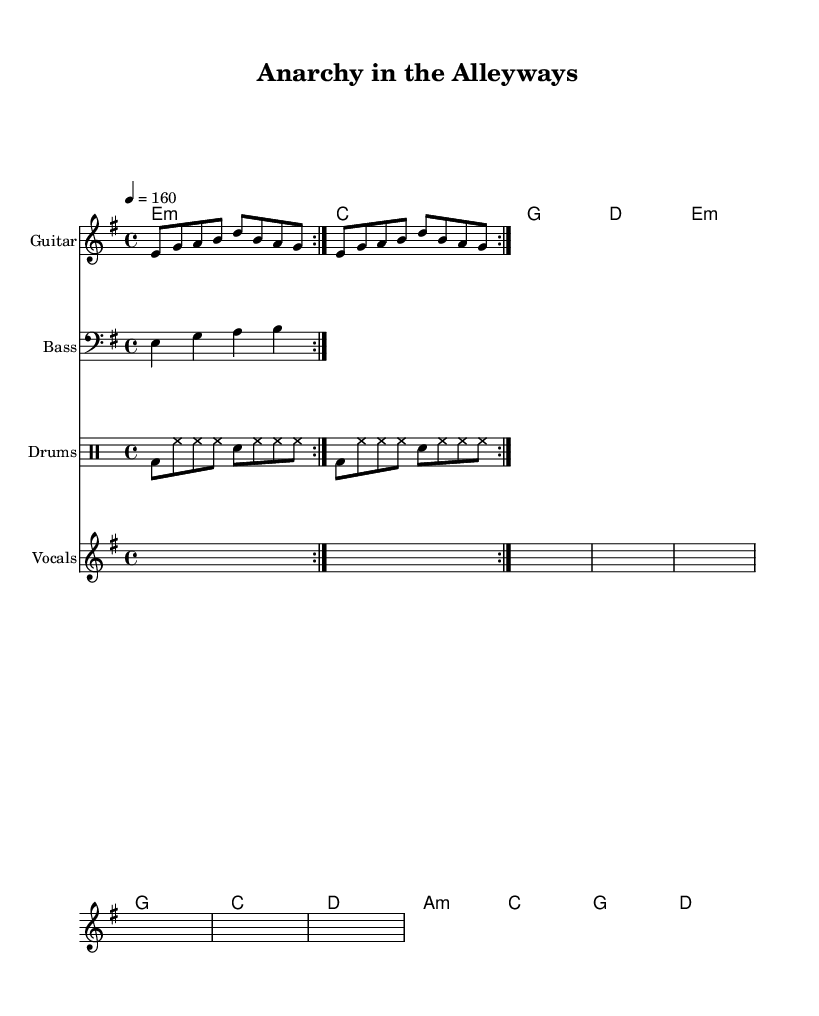What is the key signature of this music? The key signature for the piece is E minor, which has one sharp (F#). The key signature is indicated at the beginning of the staff.
Answer: E minor What is the time signature of this music? The time signature is 4/4, meaning there are four beats in each measure, and the quarter note gets one beat. This is shown at the start of the score.
Answer: 4/4 What is the tempo marking of the piece? The tempo marking is 4 = 160, indicating that the quarter note is to be played at a speed of 160 beats per minute. This is stated underneath the global settings.
Answer: 160 How many times is the guitar riff repeated in the section? The guitar riff is repeated two times based on the repeat markings in the score. The repetitions are shown by the volta sign, indicating to play the music twice.
Answer: 2 What are the main themes expressed in the lyrics? The lyrics convey themes of chaos and rebellion, reflecting an anti-establishment sentiment typical of punk music. Phrases such as "No more rules" and "tear - ing down the old dis - plays" highlight a critique of the status quo.
Answer: rebellion and chaos What is the chord progression in the verse? In the verse, the chord progression is E minor, C, G, D. This can be traced through the chord symbols written above the staff.
Answer: E minor, C, G, D What instrument plays the drum pattern? The drum pattern is played on the drums, as indicated by the specific notation and identified staff in the score labeled "Drums."
Answer: Drums 